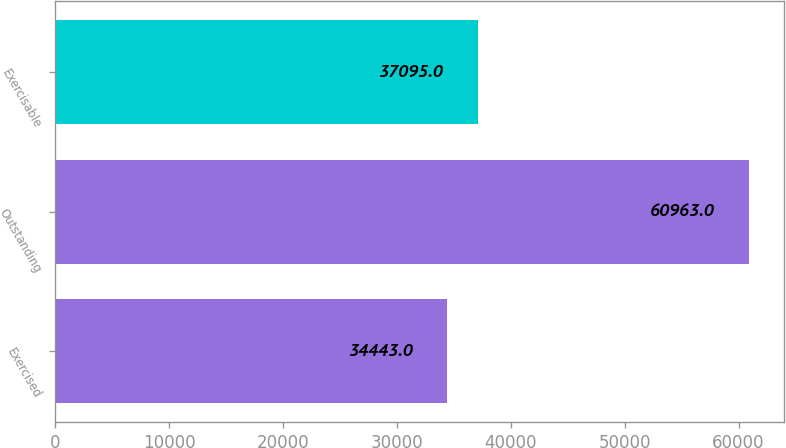<chart> <loc_0><loc_0><loc_500><loc_500><bar_chart><fcel>Exercised<fcel>Outstanding<fcel>Exercisable<nl><fcel>34443<fcel>60963<fcel>37095<nl></chart> 